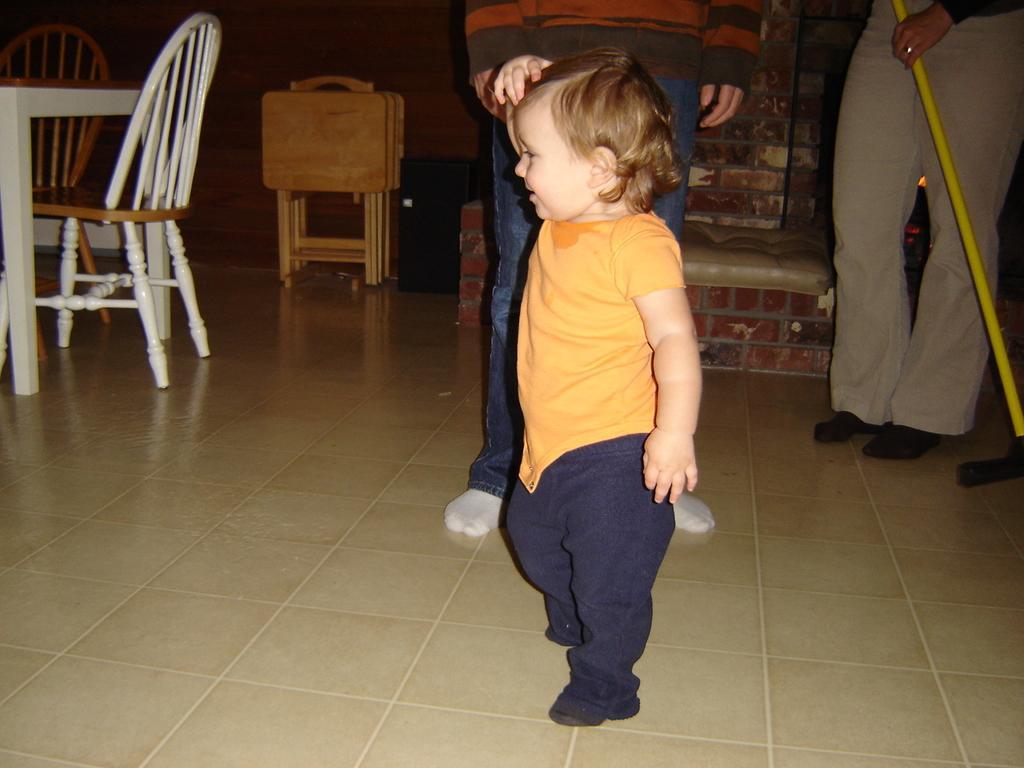Describe this image in one or two sentences. In this image I see a child and there are persons behind the child. I can also see 2 chairs and a table over here and I see the wall. 